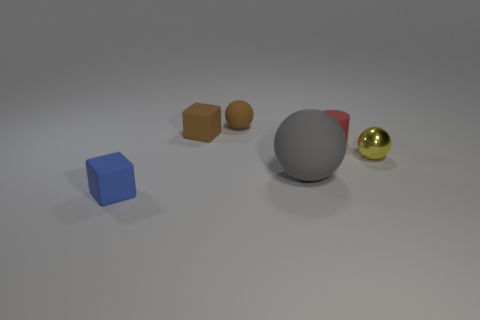Is the size of the cube that is behind the blue matte block the same as the big object?
Make the answer very short. No. How many cubes are in front of the tiny cylinder?
Provide a short and direct response. 1. Is the number of tiny brown things in front of the large ball less than the number of big matte spheres that are behind the tiny brown matte cube?
Your answer should be very brief. No. What number of red rubber cylinders are there?
Provide a short and direct response. 1. There is a cube that is behind the tiny metallic object; what is its color?
Provide a succinct answer. Brown. How big is the brown matte ball?
Offer a very short reply. Small. There is a metal ball; is its color the same as the small rubber object in front of the red matte thing?
Ensure brevity in your answer.  No. What color is the rubber ball that is behind the sphere to the right of the gray ball?
Provide a succinct answer. Brown. Is there anything else that is the same size as the yellow thing?
Your answer should be very brief. Yes. There is a tiny matte thing that is in front of the yellow object; does it have the same shape as the big gray rubber thing?
Keep it short and to the point. No. 